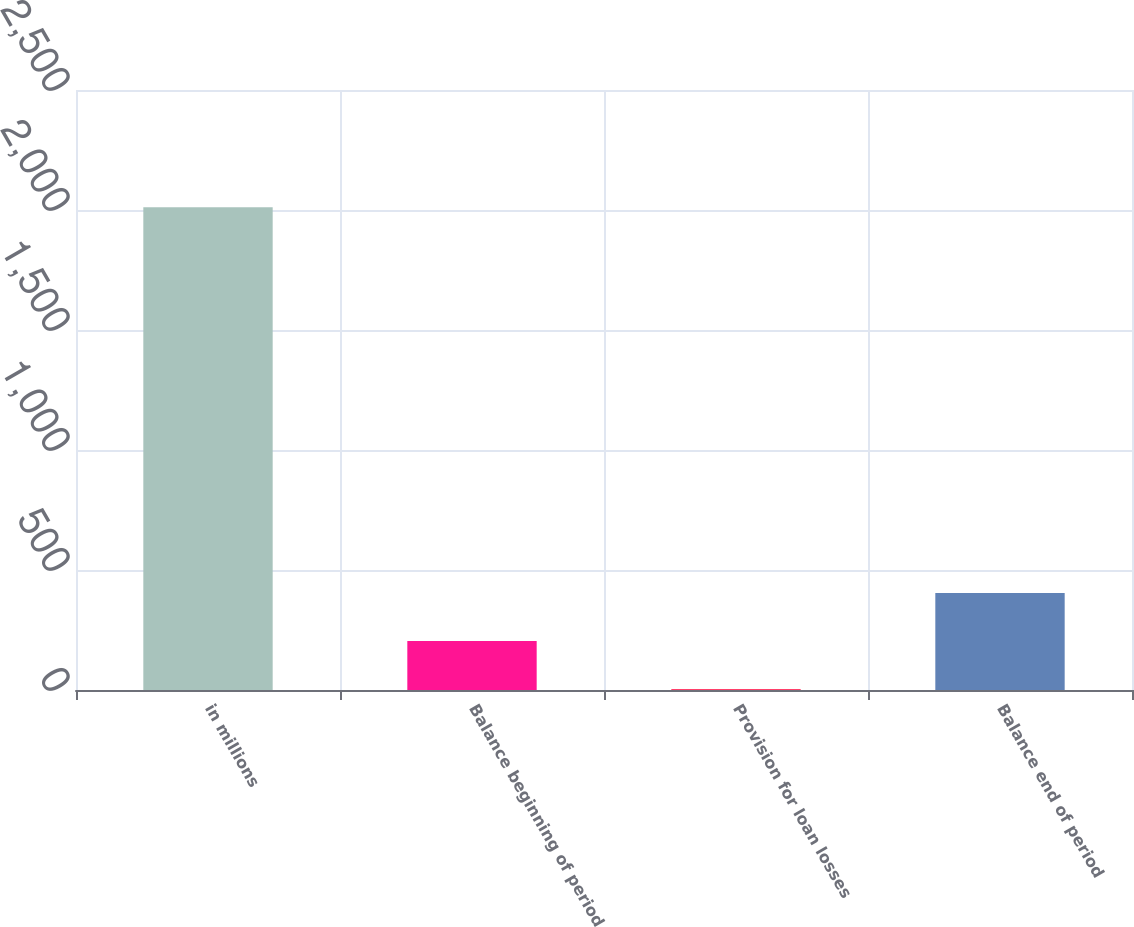Convert chart to OTSL. <chart><loc_0><loc_0><loc_500><loc_500><bar_chart><fcel>in millions<fcel>Balance beginning of period<fcel>Provision for loan losses<fcel>Balance end of period<nl><fcel>2011<fcel>203.8<fcel>3<fcel>404.6<nl></chart> 